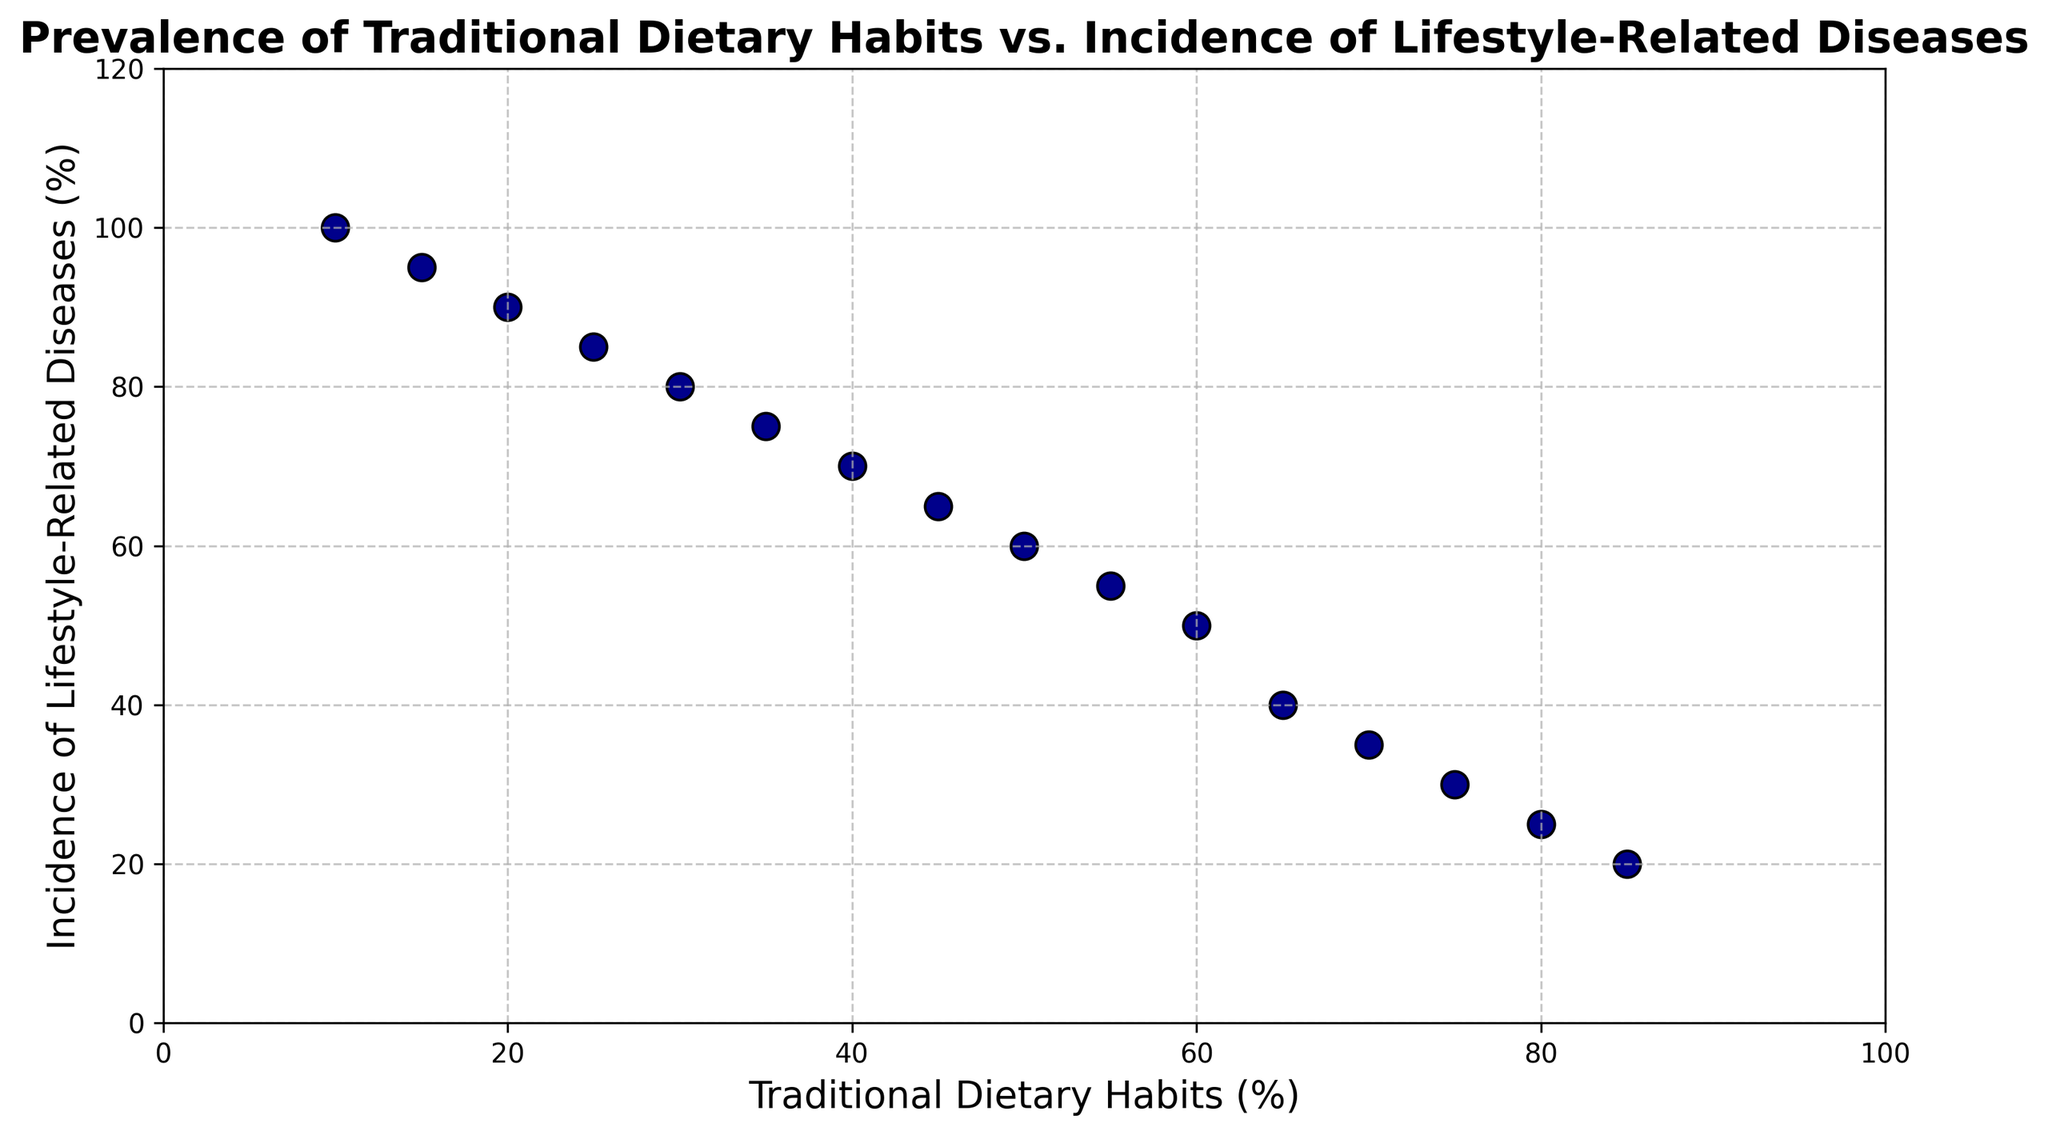What is the general trend shown in the scatter plot? The scatter plot shows a negative correlation between the prevalence of traditional dietary habits and the incidence of lifestyle-related diseases. As the prevalence of traditional dietary habits decreases, the incidence of lifestyle-related diseases increases.
Answer: Negative correlation At what level of traditional dietary habits does the incidence of lifestyle-related diseases first reach 50%? By observing the scatter plot, we see that the incidence of lifestyle-related diseases reaches 50% when the traditional dietary habits are at 60%.
Answer: 60% What is the incidence of lifestyle-related diseases when the prevalence of traditional dietary habits is 25%? Looking at the scatter plot, we can identify the data point where traditional dietary habits are 25%. The corresponding incidence of lifestyle-related diseases is 85%.
Answer: 85% Is there any point where the incidence of lifestyle diseases is below 30%? Referring to the scatter plot, we observe that there is a point where the incidence of lifestyle diseases is 25% when the traditional dietary habits are at 80%.
Answer: Yes What is the difference in the incidence of lifestyle-related diseases between traditional dietary habits at 85% and 10%? At 85% traditional dietary habits, the incidence is 20%, and at 10%, it is 100%. The difference is 100% - 20% = 80%.
Answer: 80% Which value of traditional dietary habits corresponds to the highest incidence of lifestyle-related diseases? By looking at the scatter plot, the highest incidence of lifestyle-related diseases (100%) corresponds to the traditional dietary habits value of 10%.
Answer: 10% What can we infer about a community with a traditional dietary habits prevalence of 35%? By finding the corresponding point on the scatter plot, we infer that the incidence of lifestyle-related diseases in communities with a 35% prevalence of traditional dietary habits is 75%.
Answer: 75% How does the incidence of lifestyle-related diseases progress as the prevalence of traditional dietary habits reduces from 85% to 45%? Observing the scatter plot, as the prevalence of traditional dietary habits reduces from 85% to 45%, the incidence of lifestyle-related diseases increases consistently from 20% to 65%.
Answer: Consistent increase What's the average incidence of lifestyle-related diseases for traditional dietary habits ranging from 30% to 60%? For traditional dietary habits at 30%, 35%, 40%, 45%, 50%, 55%, and 60%, the incidence is 80%, 75%, 70%, 65%, 60%, 55%, and 50%, respectively. The sum is 455, and we divide it by 7 to achieve an average of about 65%.
Answer: 65% 